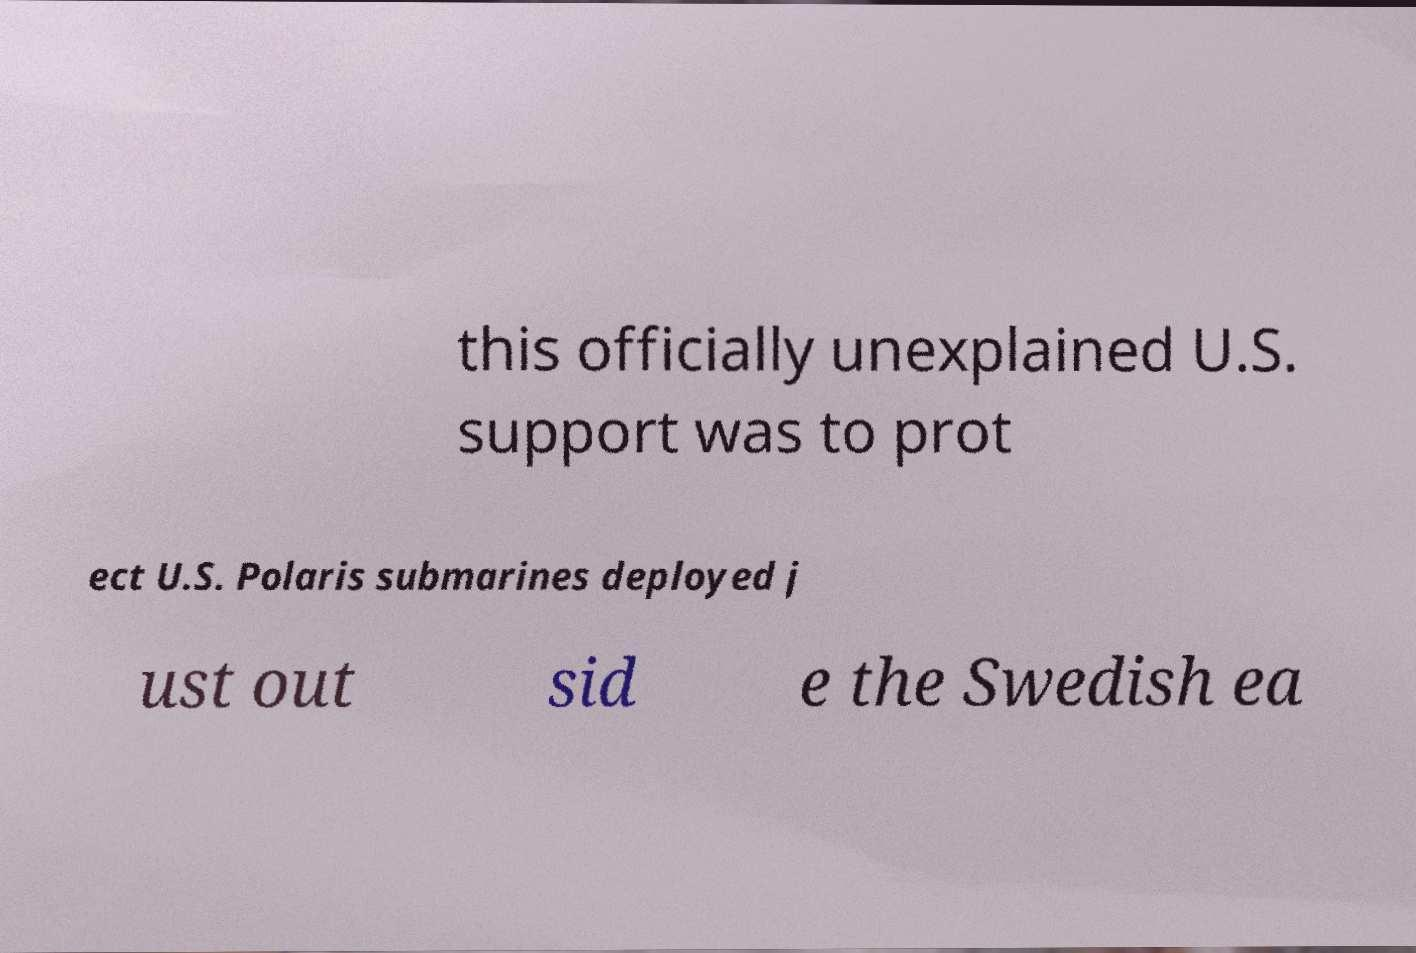Please read and relay the text visible in this image. What does it say? this officially unexplained U.S. support was to prot ect U.S. Polaris submarines deployed j ust out sid e the Swedish ea 